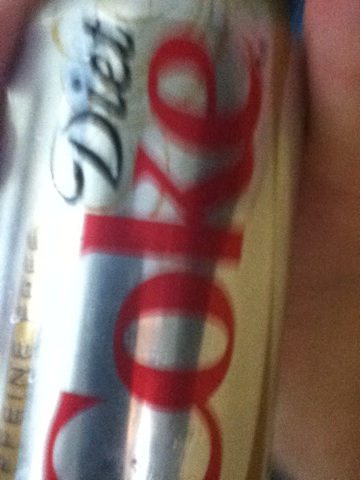Could you provide some history about Diet Coke? Diet Coke was introduced in 1982 as a sugar-free alternative to regular Coca-Cola. It quickly became one of the most popular soft drinks in the world, especially among consumers seeking a low-calorie option. Its formula differs from that of Coca-Cola, giving it a distinct taste that many have come to prefer. Has Diet Coke changed its formula or packaging over the years? Yes, Diet Coke has seen several packaging redesigns over the years, including limited edition art and new can sizes. The formula has remained largely consistent, with the exception of slight modifications and the introduction of new flavors and variations like Diet Coke with Lime, Cherry, Vanilla, and Diet Coke Caffeine-Free. 